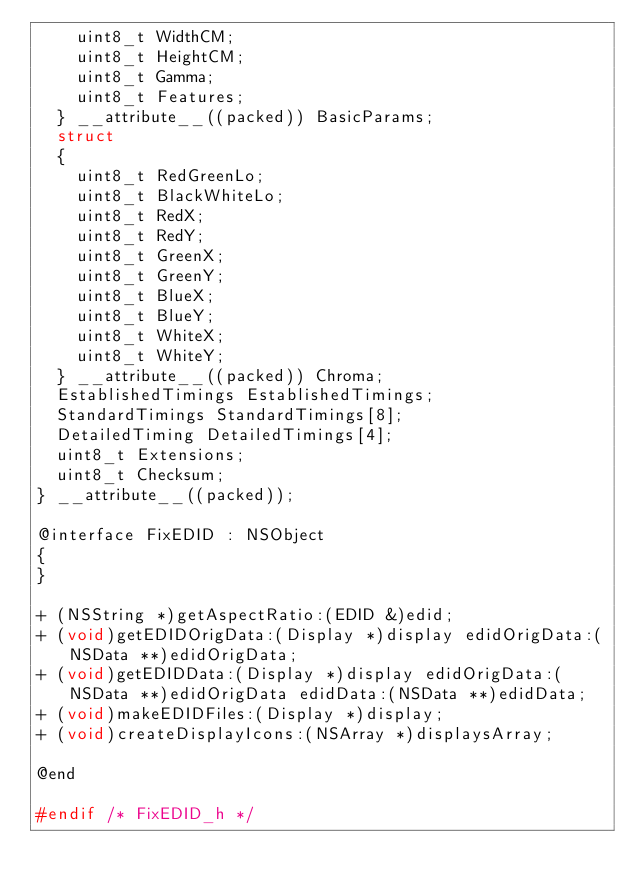<code> <loc_0><loc_0><loc_500><loc_500><_C_>		uint8_t WidthCM;
		uint8_t HeightCM;
		uint8_t Gamma;
		uint8_t Features;
	} __attribute__((packed)) BasicParams;
	struct
	{
		uint8_t RedGreenLo;
		uint8_t BlackWhiteLo;
		uint8_t RedX;
		uint8_t RedY;
		uint8_t GreenX;
		uint8_t GreenY;
		uint8_t BlueX;
		uint8_t BlueY;
		uint8_t WhiteX;
		uint8_t WhiteY;
	} __attribute__((packed)) Chroma;
	EstablishedTimings EstablishedTimings;
	StandardTimings StandardTimings[8];
	DetailedTiming DetailedTimings[4];
	uint8_t Extensions;
	uint8_t Checksum;
} __attribute__((packed));

@interface FixEDID : NSObject
{
}

+ (NSString *)getAspectRatio:(EDID &)edid;
+ (void)getEDIDOrigData:(Display *)display edidOrigData:(NSData **)edidOrigData;
+ (void)getEDIDData:(Display *)display edidOrigData:(NSData **)edidOrigData edidData:(NSData **)edidData;
+ (void)makeEDIDFiles:(Display *)display;
+ (void)createDisplayIcons:(NSArray *)displaysArray;

@end

#endif /* FixEDID_h */
</code> 